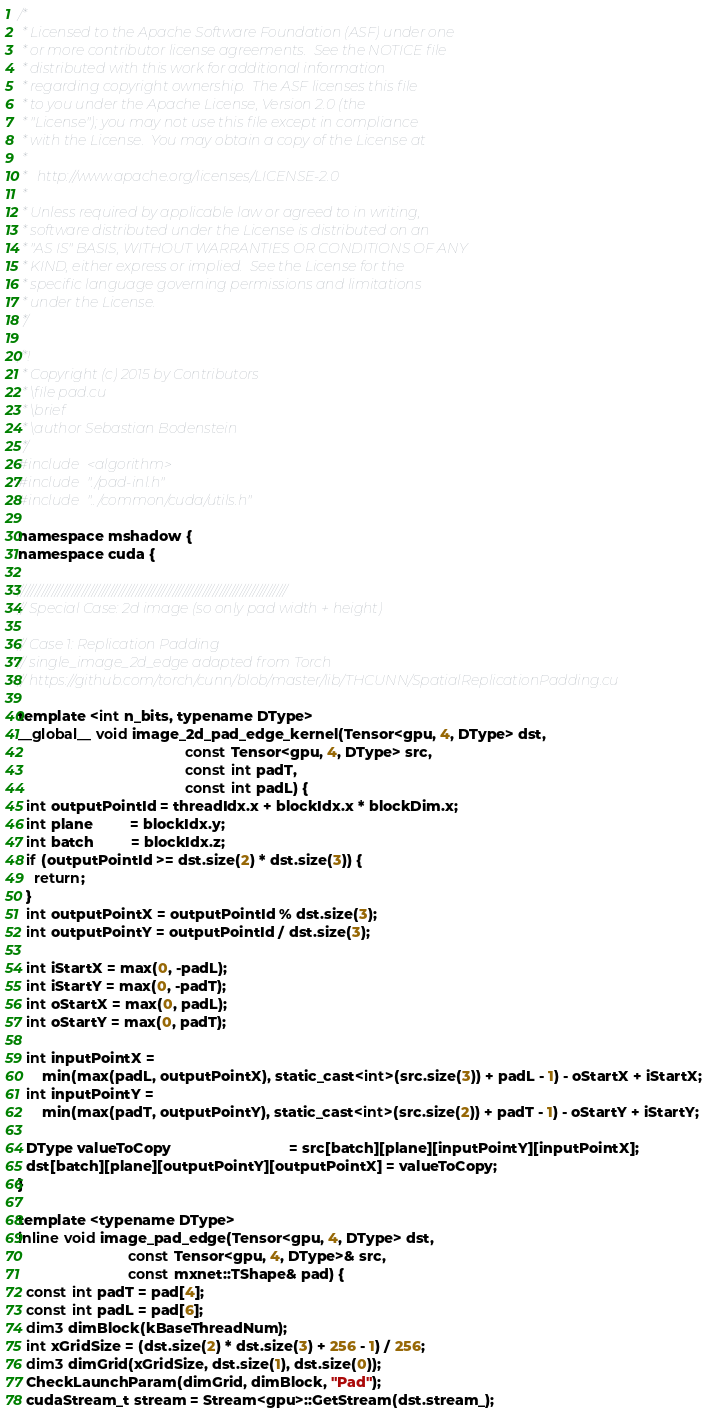Convert code to text. <code><loc_0><loc_0><loc_500><loc_500><_Cuda_>/*
 * Licensed to the Apache Software Foundation (ASF) under one
 * or more contributor license agreements.  See the NOTICE file
 * distributed with this work for additional information
 * regarding copyright ownership.  The ASF licenses this file
 * to you under the Apache License, Version 2.0 (the
 * "License"); you may not use this file except in compliance
 * with the License.  You may obtain a copy of the License at
 *
 *   http://www.apache.org/licenses/LICENSE-2.0
 *
 * Unless required by applicable law or agreed to in writing,
 * software distributed under the License is distributed on an
 * "AS IS" BASIS, WITHOUT WARRANTIES OR CONDITIONS OF ANY
 * KIND, either express or implied.  See the License for the
 * specific language governing permissions and limitations
 * under the License.
 */

/*!
 * Copyright (c) 2015 by Contributors
 * \file pad.cu
 * \brief
 * \author Sebastian Bodenstein
 */
#include <algorithm>
#include "./pad-inl.h"
#include "../common/cuda/utils.h"

namespace mshadow {
namespace cuda {

////////////////////////////////////////////////////////////////////////////////
// Special Case: 2d image (so only pad width + height)

// Case 1: Replication Padding
// single_image_2d_edge adapted from Torch
// https://github.com/torch/cunn/blob/master/lib/THCUNN/SpatialReplicationPadding.cu

template <int n_bits, typename DType>
__global__ void image_2d_pad_edge_kernel(Tensor<gpu, 4, DType> dst,
                                         const Tensor<gpu, 4, DType> src,
                                         const int padT,
                                         const int padL) {
  int outputPointId = threadIdx.x + blockIdx.x * blockDim.x;
  int plane         = blockIdx.y;
  int batch         = blockIdx.z;
  if (outputPointId >= dst.size(2) * dst.size(3)) {
    return;
  }
  int outputPointX = outputPointId % dst.size(3);
  int outputPointY = outputPointId / dst.size(3);

  int iStartX = max(0, -padL);
  int iStartY = max(0, -padT);
  int oStartX = max(0, padL);
  int oStartY = max(0, padT);

  int inputPointX =
      min(max(padL, outputPointX), static_cast<int>(src.size(3)) + padL - 1) - oStartX + iStartX;
  int inputPointY =
      min(max(padT, outputPointY), static_cast<int>(src.size(2)) + padT - 1) - oStartY + iStartY;

  DType valueToCopy                             = src[batch][plane][inputPointY][inputPointX];
  dst[batch][plane][outputPointY][outputPointX] = valueToCopy;
}

template <typename DType>
inline void image_pad_edge(Tensor<gpu, 4, DType> dst,
                           const Tensor<gpu, 4, DType>& src,
                           const mxnet::TShape& pad) {
  const int padT = pad[4];
  const int padL = pad[6];
  dim3 dimBlock(kBaseThreadNum);
  int xGridSize = (dst.size(2) * dst.size(3) + 256 - 1) / 256;
  dim3 dimGrid(xGridSize, dst.size(1), dst.size(0));
  CheckLaunchParam(dimGrid, dimBlock, "Pad");
  cudaStream_t stream = Stream<gpu>::GetStream(dst.stream_);</code> 